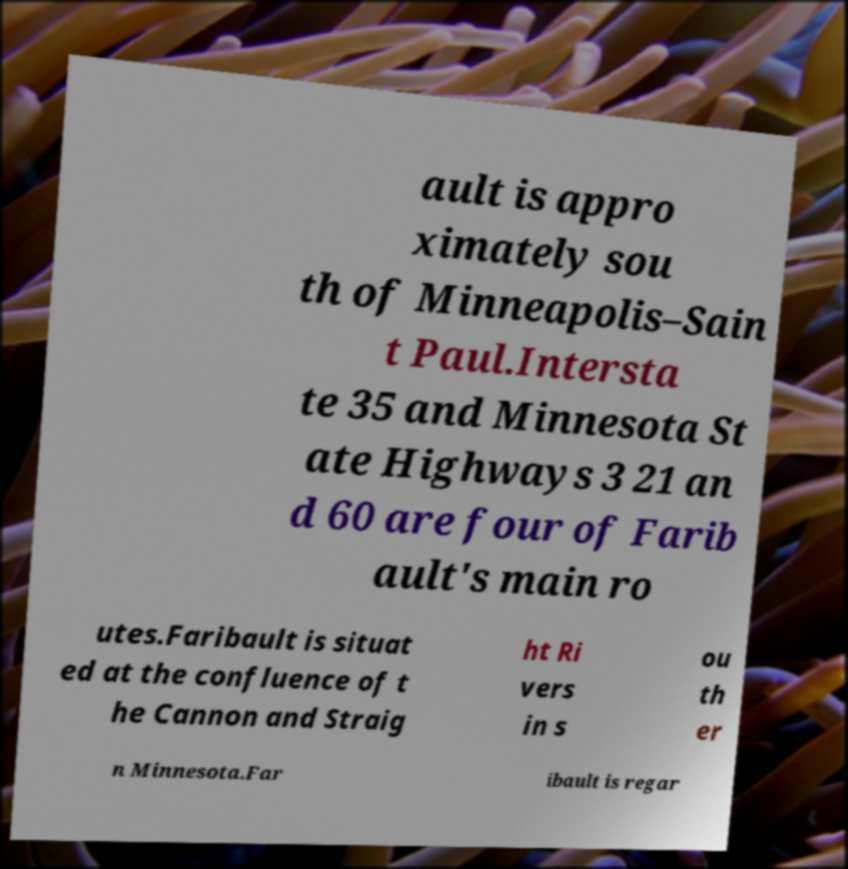Please read and relay the text visible in this image. What does it say? ault is appro ximately sou th of Minneapolis–Sain t Paul.Intersta te 35 and Minnesota St ate Highways 3 21 an d 60 are four of Farib ault's main ro utes.Faribault is situat ed at the confluence of t he Cannon and Straig ht Ri vers in s ou th er n Minnesota.Far ibault is regar 